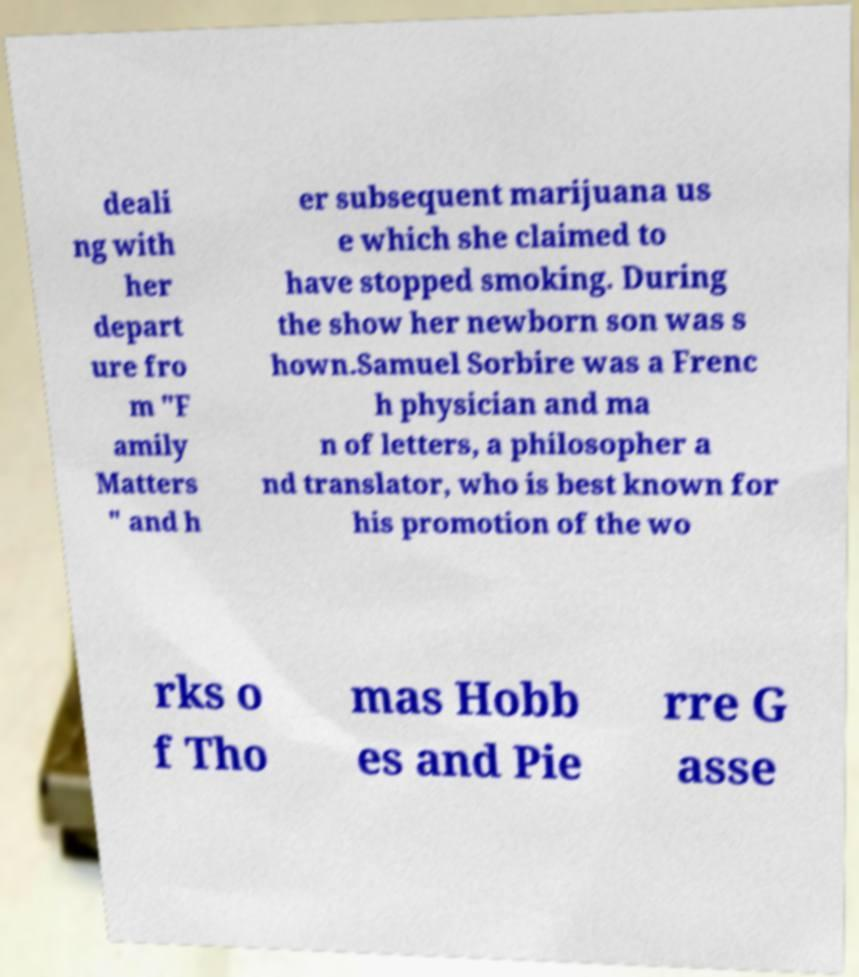What messages or text are displayed in this image? I need them in a readable, typed format. deali ng with her depart ure fro m "F amily Matters " and h er subsequent marijuana us e which she claimed to have stopped smoking. During the show her newborn son was s hown.Samuel Sorbire was a Frenc h physician and ma n of letters, a philosopher a nd translator, who is best known for his promotion of the wo rks o f Tho mas Hobb es and Pie rre G asse 